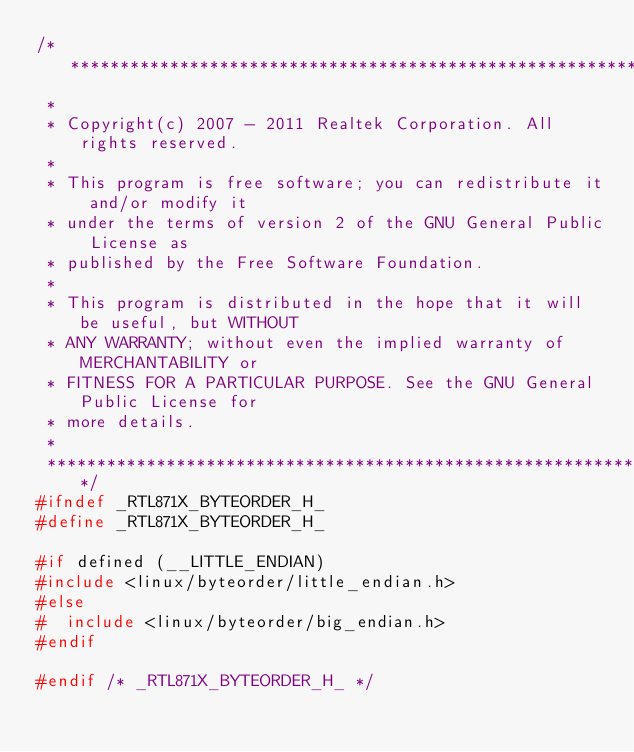Convert code to text. <code><loc_0><loc_0><loc_500><loc_500><_C_>/******************************************************************************
 *
 * Copyright(c) 2007 - 2011 Realtek Corporation. All rights reserved.
 *
 * This program is free software; you can redistribute it and/or modify it
 * under the terms of version 2 of the GNU General Public License as
 * published by the Free Software Foundation.
 *
 * This program is distributed in the hope that it will be useful, but WITHOUT
 * ANY WARRANTY; without even the implied warranty of MERCHANTABILITY or
 * FITNESS FOR A PARTICULAR PURPOSE. See the GNU General Public License for
 * more details.
 *
 ******************************************************************************/
#ifndef _RTL871X_BYTEORDER_H_
#define _RTL871X_BYTEORDER_H_

#if defined (__LITTLE_ENDIAN)
#include <linux/byteorder/little_endian.h>
#else
#  include <linux/byteorder/big_endian.h>
#endif

#endif /* _RTL871X_BYTEORDER_H_ */
</code> 